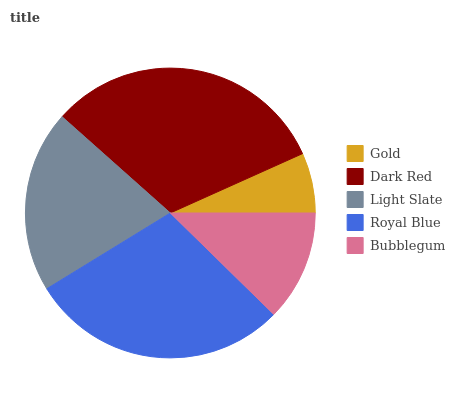Is Gold the minimum?
Answer yes or no. Yes. Is Dark Red the maximum?
Answer yes or no. Yes. Is Light Slate the minimum?
Answer yes or no. No. Is Light Slate the maximum?
Answer yes or no. No. Is Dark Red greater than Light Slate?
Answer yes or no. Yes. Is Light Slate less than Dark Red?
Answer yes or no. Yes. Is Light Slate greater than Dark Red?
Answer yes or no. No. Is Dark Red less than Light Slate?
Answer yes or no. No. Is Light Slate the high median?
Answer yes or no. Yes. Is Light Slate the low median?
Answer yes or no. Yes. Is Royal Blue the high median?
Answer yes or no. No. Is Gold the low median?
Answer yes or no. No. 